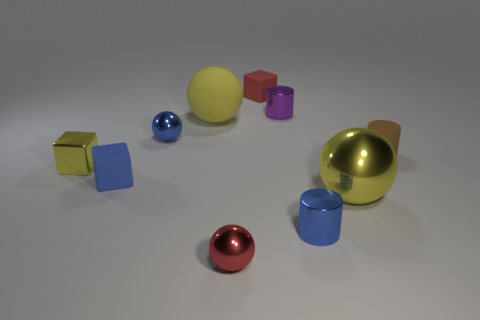Are there the same number of metallic cylinders and tiny red rubber blocks?
Your answer should be compact. No. Is there another purple object that has the same shape as the large metallic thing?
Your answer should be compact. No. There is a metal cylinder in front of the big matte sphere; is it the same size as the blue metal ball on the left side of the small purple cylinder?
Provide a succinct answer. Yes. Are there fewer tiny yellow metallic objects to the left of the small red ball than blue metallic spheres in front of the small brown thing?
Your answer should be compact. No. There is a small cube that is the same color as the big metal thing; what is its material?
Make the answer very short. Metal. The large thing behind the large yellow metal ball is what color?
Make the answer very short. Yellow. Is the shiny cube the same color as the matte ball?
Keep it short and to the point. Yes. What number of small yellow metal objects are in front of the sphere that is on the right side of the metal cylinder that is in front of the small blue rubber cube?
Give a very brief answer. 0. What is the size of the blue block?
Ensure brevity in your answer.  Small. There is a blue sphere that is the same size as the blue rubber object; what is its material?
Provide a succinct answer. Metal. 